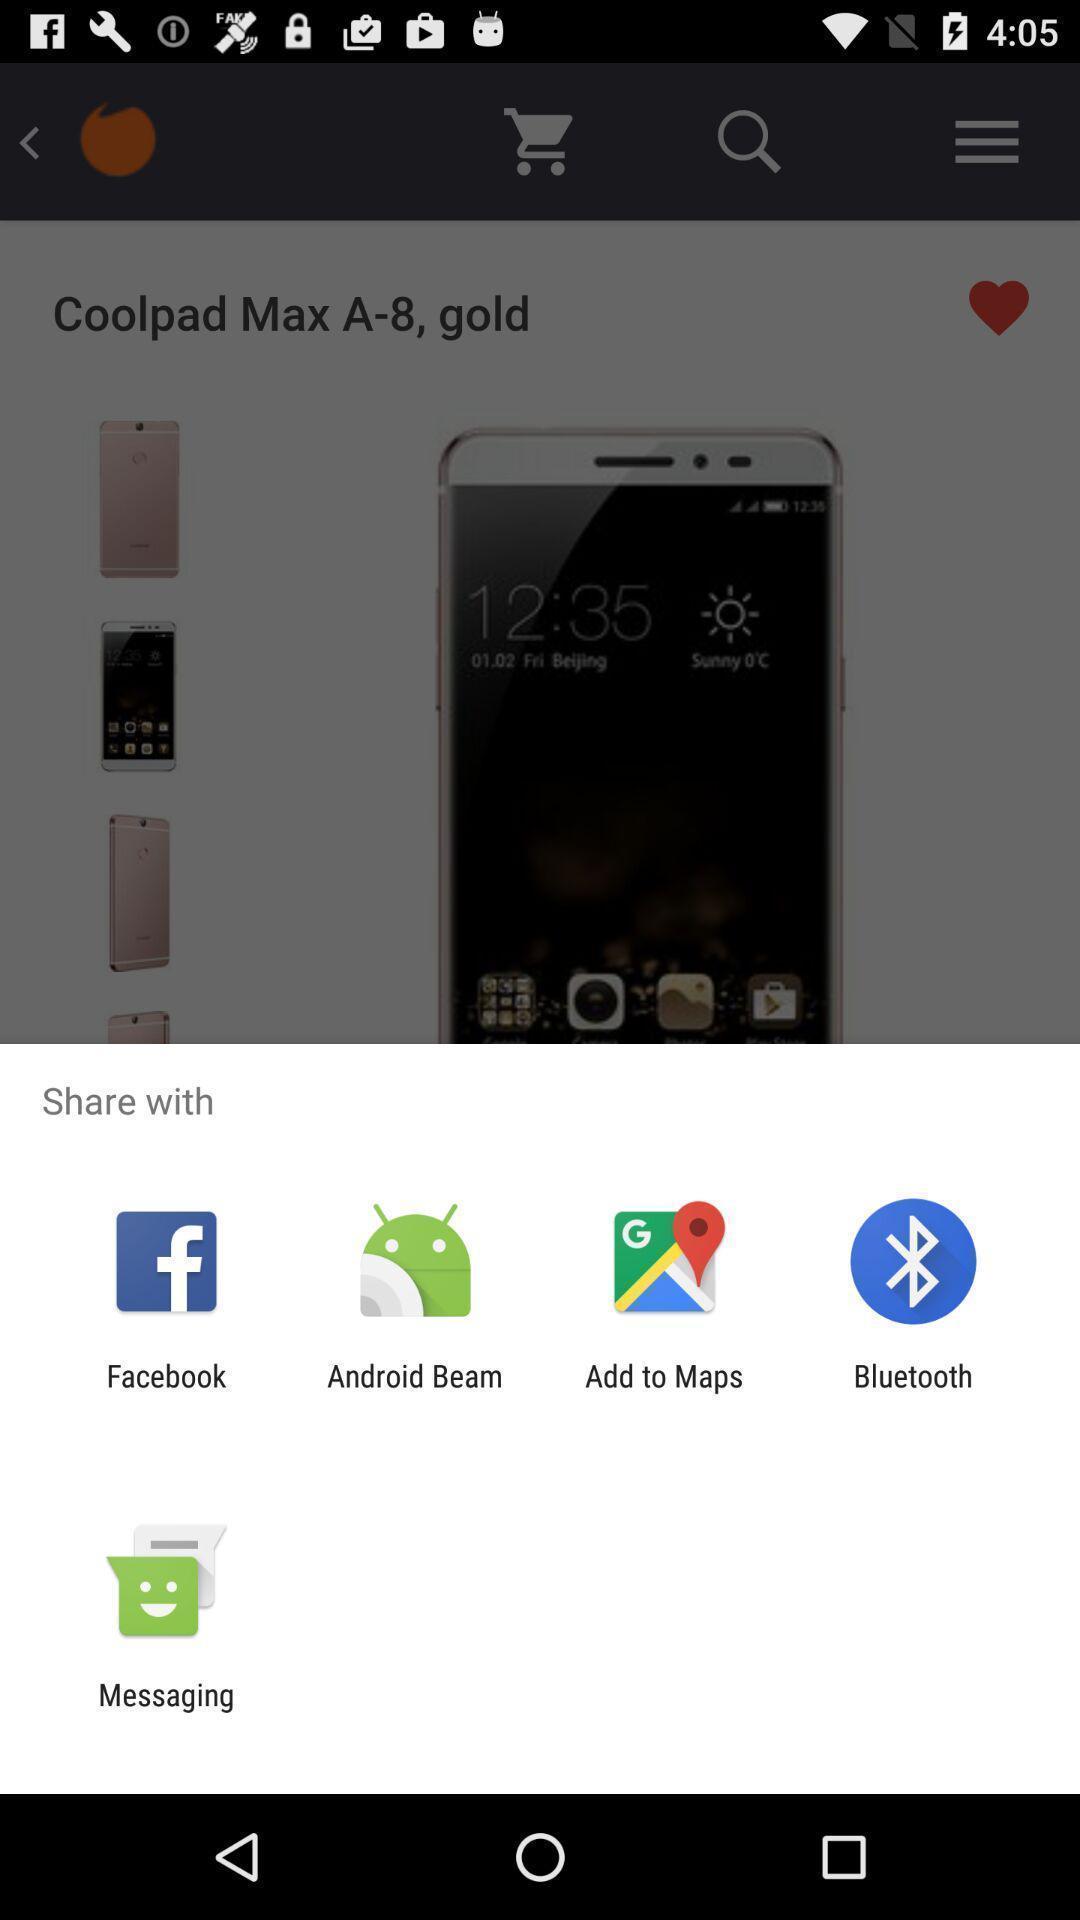Describe the key features of this screenshot. Widget showing multiple data sharing applications. 